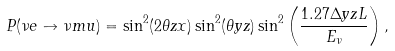<formula> <loc_0><loc_0><loc_500><loc_500>P ( \nu e \to \nu m u ) = \sin ^ { 2 } ( 2 \theta z x ) \sin ^ { 2 } ( \theta y z ) \sin ^ { 2 } \left ( \frac { 1 . 2 7 \Delta y z L } { E _ { \nu } } \right ) ,</formula> 